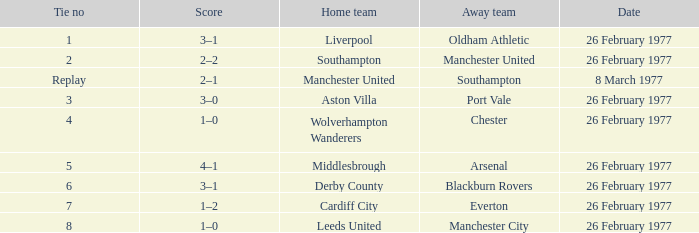What's the score when the Wolverhampton Wanderers played at home? 1–0. 